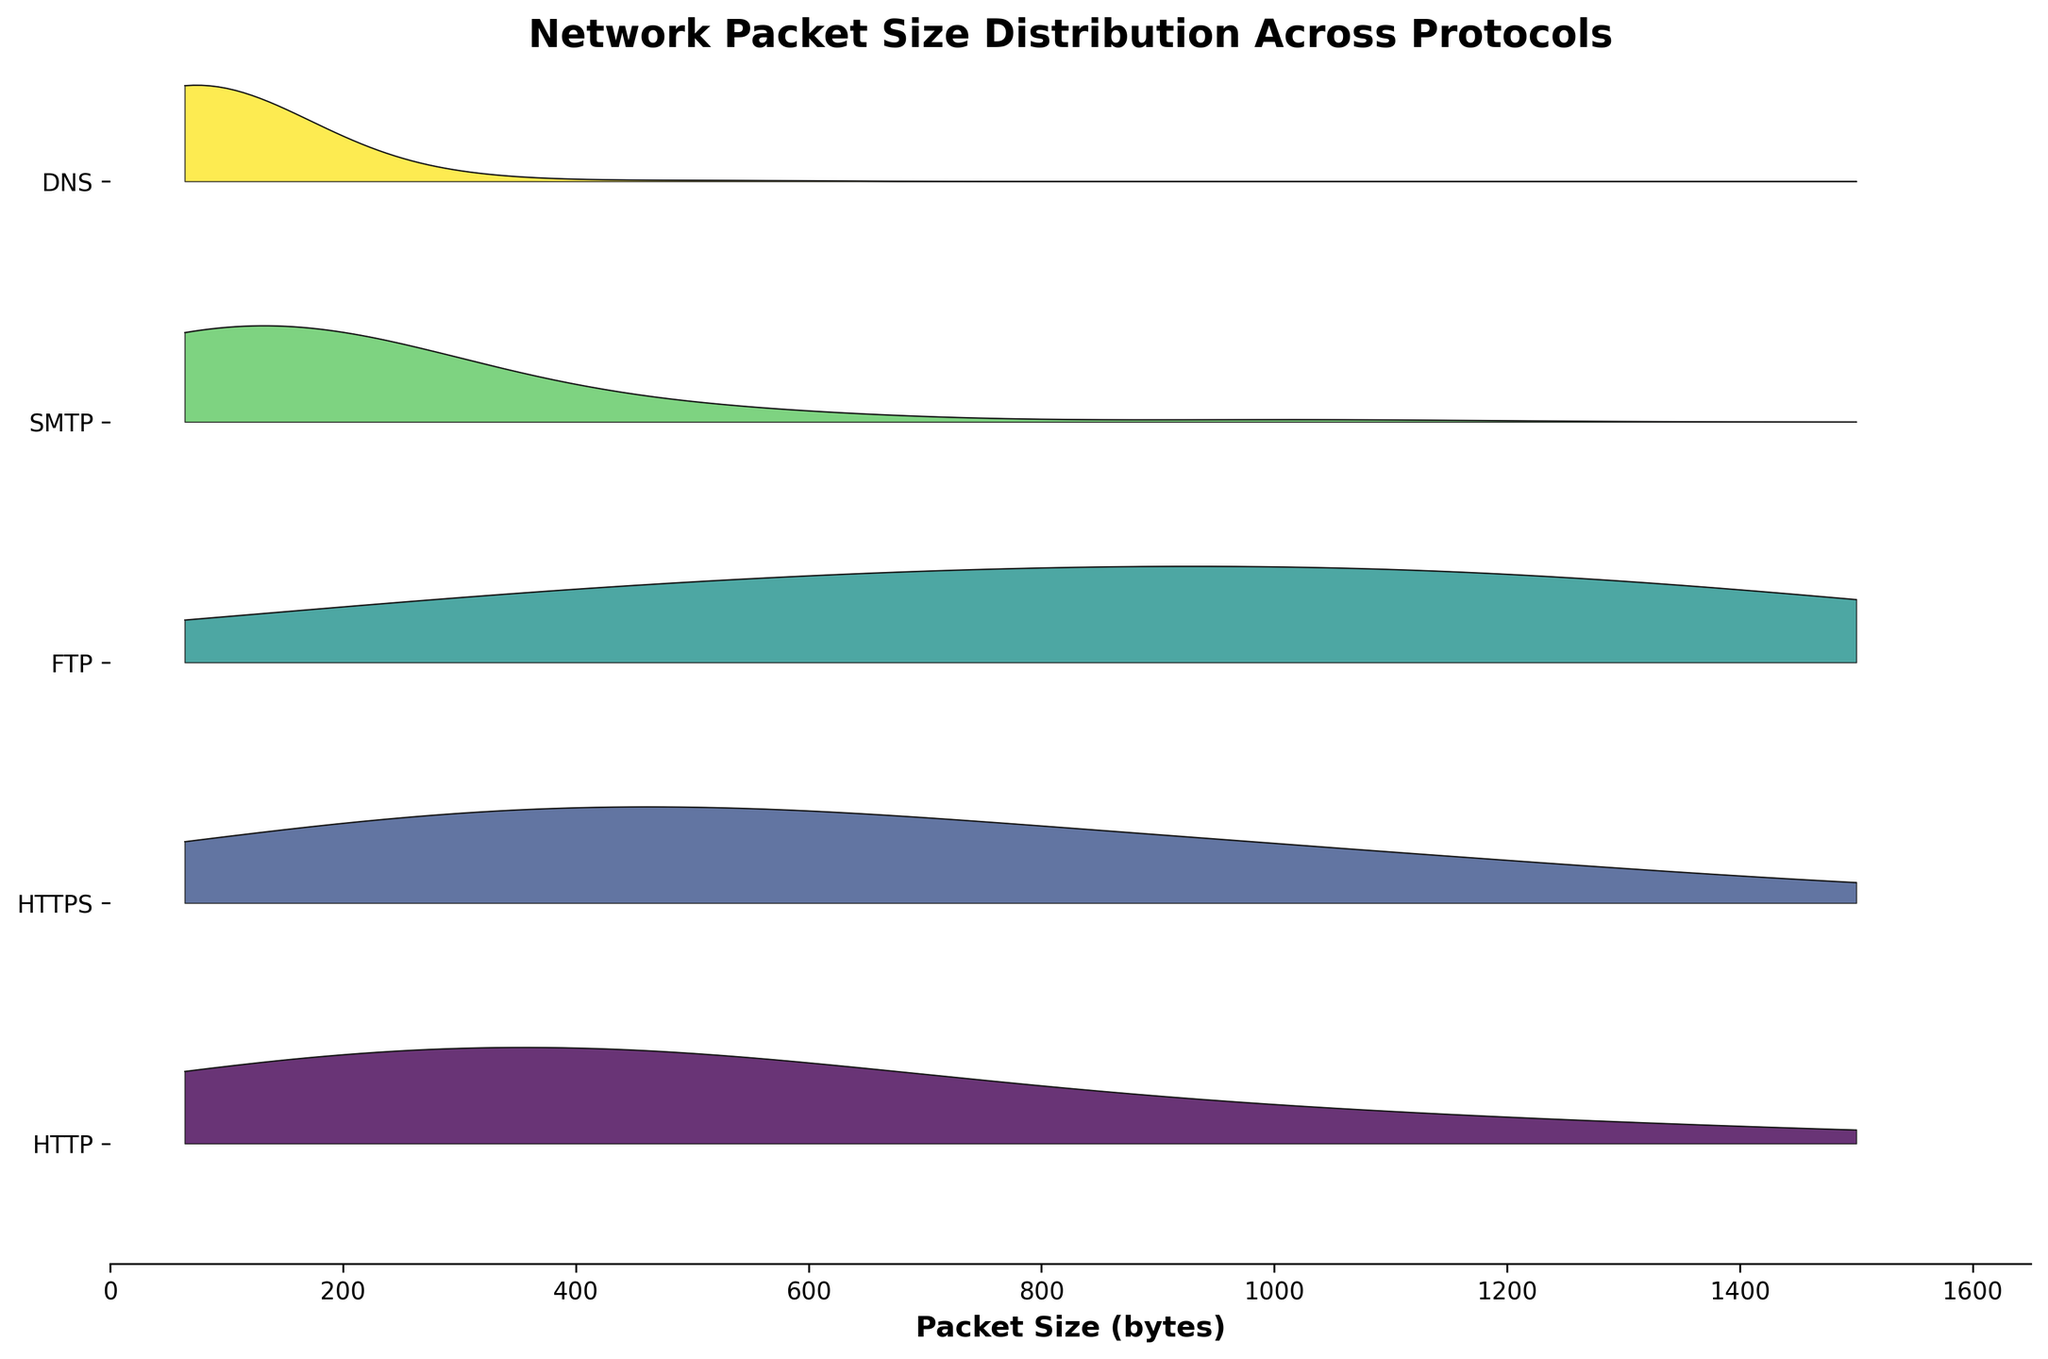What is the title of the plot? The title is typically found at the top of the plot, describing what the plot is about. In this case, it reads "Network Packet Size Distribution Across Protocols".
Answer: Network Packet Size Distribution Across Protocols How many protocols are represented in the plot? The number of protocols can be counted from the y-axis labels. Each label represents one protocol.
Answer: 5 Which protocol has the highest frequency of packet sizes around 64 bytes? By looking at the heights of the ridgelines at the 64-byte mark, the DNS protocol has the highest peak for packet sizes around 64 bytes.
Answer: DNS Which two protocols have the most similar distributions of packet sizes? Comparing the shapes and the heights of the ridgelines, HTTP and HTTPS have distributions that are quite similar, both having their highest peaks around 512 bytes.
Answer: HTTP and HTTPS How does the packet size distribution for SMTP compare to DNS? DNS has a very high concentration of small packet sizes around 64 bytes, while SMTP has a wider distribution with peaks at both 64 and 128 bytes.
Answer: DNS is concentrated at 64 bytes; SMTP is spread between 64 and 128 bytes What is the most common packet size for the FTP protocol? The peak of the FTP ridgeline indicates the most common packet size. The highest peak is at the 1024-byte mark.
Answer: 1024 bytes Which protocol has the smallest spread in packet size distribution? A smaller spread means there are fewer peaks and data is concentrated around certain packet sizes. DNS has most of its values concentrated around 64 bytes, showing the smallest spread.
Answer: DNS Are there any protocols with no packets larger than 1500 bytes? By observing the ridgelines at the 1500-byte mark, we can see that SMTP and DNS have zero frequencies at this size.
Answer: SMTP and DNS How does the height of the HTTP ridgeline at 256 bytes compare to its height at 512 bytes? By observing the relative heights at the 256-byte and 512-byte marks on the HTTP ridgeline, the height at 512 bytes is greater than at 256 bytes, suggesting higher frequency.
Answer: Lower at 256 bytes than at 512 bytes Which protocol exhibits a bimodal distribution? A bimodal distribution has two distinct peaks. Both HTTPS and SMTP exhibit two noticeable peaks in the ridgeline plot, making them bimodal.
Answer: HTTPS and SMTP 